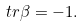Convert formula to latex. <formula><loc_0><loc_0><loc_500><loc_500>\ t r { \beta } = - 1 .</formula> 